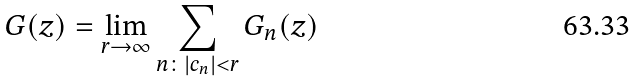Convert formula to latex. <formula><loc_0><loc_0><loc_500><loc_500>G ( z ) = \lim _ { r \to \infty } \sum _ { n \colon | c _ { n } | < r } G _ { n } ( z )</formula> 